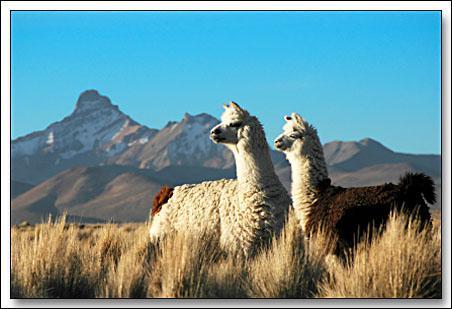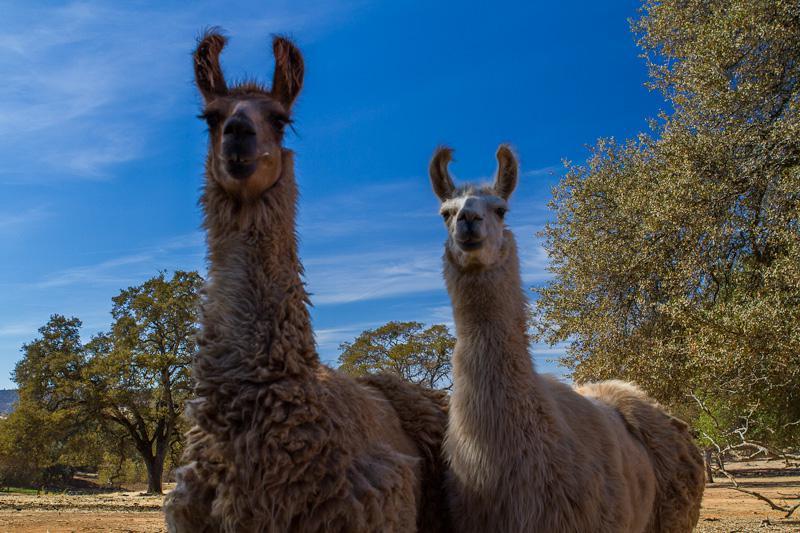The first image is the image on the left, the second image is the image on the right. Analyze the images presented: Is the assertion "There are exactly four llamas." valid? Answer yes or no. Yes. The first image is the image on the left, the second image is the image on the right. Analyze the images presented: Is the assertion "Each image shows exactly two llamas posed close together in the foreground, and a mountain peak is visible in the background of the left image." valid? Answer yes or no. Yes. 